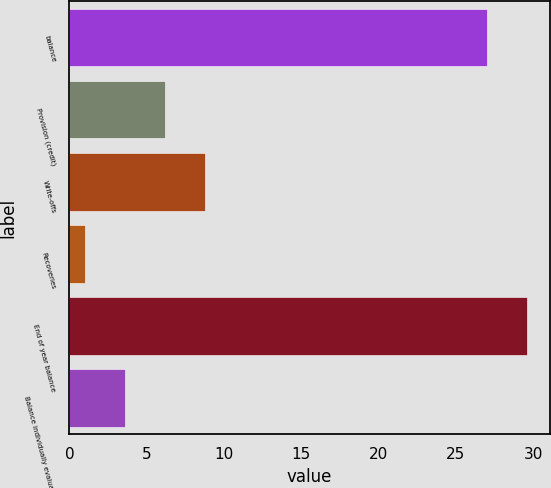Convert chart. <chart><loc_0><loc_0><loc_500><loc_500><bar_chart><fcel>balance<fcel>Provision (credit)<fcel>Write-offs<fcel>Recoveries<fcel>End of year balance<fcel>Balance individually evaluated<nl><fcel>27<fcel>6.2<fcel>8.8<fcel>1<fcel>29.6<fcel>3.6<nl></chart> 